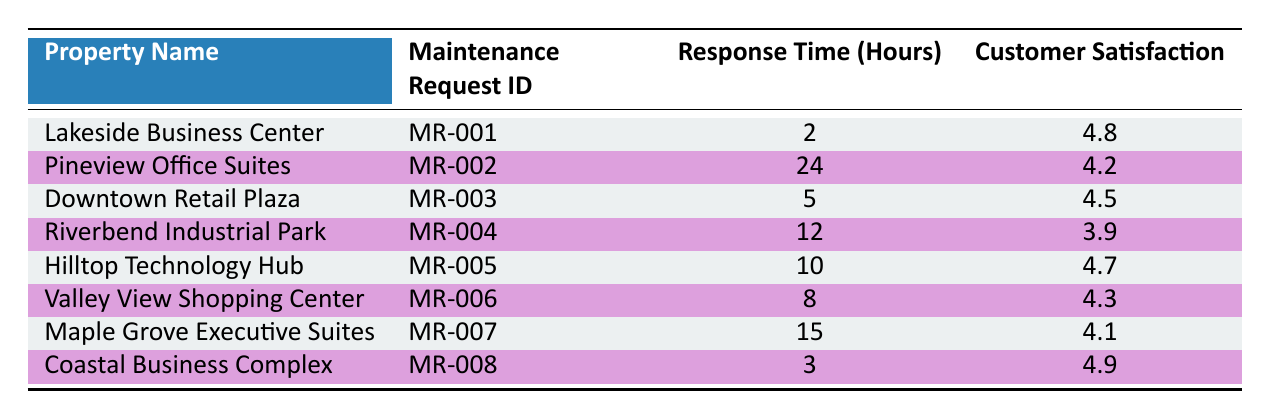What is the maintenance response time for Lakeside Business Center? According to the table, the response time for Lakeside Business Center is listed directly in the Response Time (Hours) column. It shows 2 hours.
Answer: 2 hours Which property has the highest customer satisfaction rating? By examining the Customer Satisfaction column, I can see that Coastal Business Complex has the highest rating of 4.9.
Answer: Coastal Business Complex Is the response time for Riverbend Industrial Park less than 10 hours? The table shows that Riverbend Industrial Park has a response time of 12 hours, which is greater than 10 hours. Therefore, the statement is false.
Answer: No What is the average customer satisfaction rating for properties with a response time of 10 hours or more? First, identify the properties with 10 hours or more: Pineview Office Suites (4.2), Riverbend Industrial Park (3.9), Maple Grove Executive Suites (4.1), and Hilltop Technology Hub (4.7). Add these ratings: 4.2 + 3.9 + 4.1 + 4.7 = 16.9. There are four properties, so the average is 16.9 / 4 = 4.225.
Answer: 4.225 Is the customer satisfaction rating for Downtown Retail Plaza greater than that of Valley View Shopping Center? Downtown Retail Plaza has a rating of 4.5, while Valley View Shopping Center has a rating of 4.3. Since 4.5 is greater than 4.3, the statement is true.
Answer: Yes What is the total response time for all properties listed? To find the total response time, I will sum all response times: 2 + 24 + 5 + 12 + 10 + 8 + 15 + 3 = 79 hours.
Answer: 79 hours How many properties have a customer satisfaction rating of 4.5 or higher? By reviewing the Customer Satisfaction column, the following properties qualify: Lakeside Business Center (4.8), Downtown Retail Plaza (4.5), Hilltop Technology Hub (4.7), Valley View Shopping Center (4.3), and Coastal Business Complex (4.9). Counting those shows there are 5 properties.
Answer: 5 properties What is the difference in customer satisfaction ratings between the best and worst-rated properties? The best-rated property, Coastal Business Complex, has a satisfaction rating of 4.9, while the worst-rated property, Riverbend Industrial Park, has a rating of 3.9. To find the difference: 4.9 - 3.9 = 1.
Answer: 1 How many properties have a response time of less than 10 hours? By inspecting the Response Time (Hours) column, the properties with less than 10 hours are Lakeside Business Center (2), Downtown Retail Plaza (5), Coastal Business Complex (3), and Valley View Shopping Center (8). That's a total of 4 properties.
Answer: 4 properties 